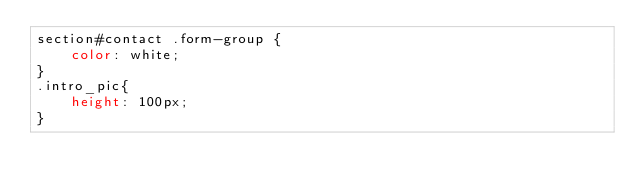Convert code to text. <code><loc_0><loc_0><loc_500><loc_500><_CSS_>section#contact .form-group {
    color: white;
}
.intro_pic{
    height: 100px;
}</code> 